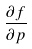<formula> <loc_0><loc_0><loc_500><loc_500>\frac { \partial f } { \partial p }</formula> 